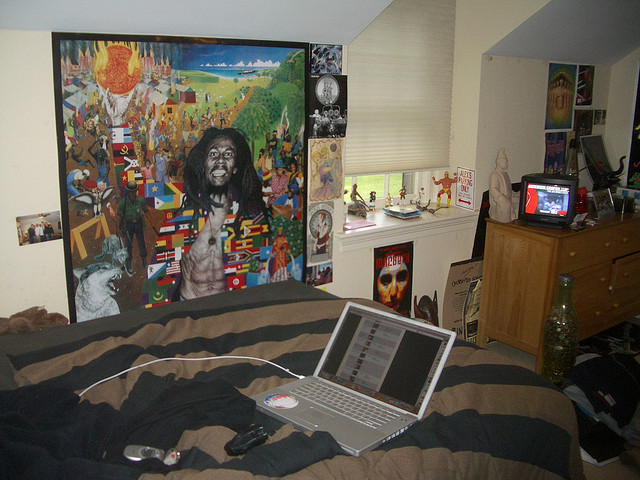<image>Who is the character to the far left? I don't know who is the character on the far left. It could be Bob Marley or someone else. What musical instrument is shown? I don't know what musical instrument is shown. It could be a guitar, saxophone, or horn. What print is on the wallpaper? I don't know exactly what the print is on the wallpaper. It can range from 'bob marley', 'african', 'island', 'reprint', 'rocky' to 'cheetah'. Who is the character to the far left? I don't know who the character to the far left is. It can be Bob Marley or someone else. What musical instrument is shown? I am not sure what musical instrument is shown. It can be seen a guitar, a laptop, a saxophone or a horn. What print is on the wallpaper? I don't know what print is on the wallpaper. It could be 'bob marley', 'african', 'solid', 'island', 'reprint', 'rocky', or 'cheetah'. 